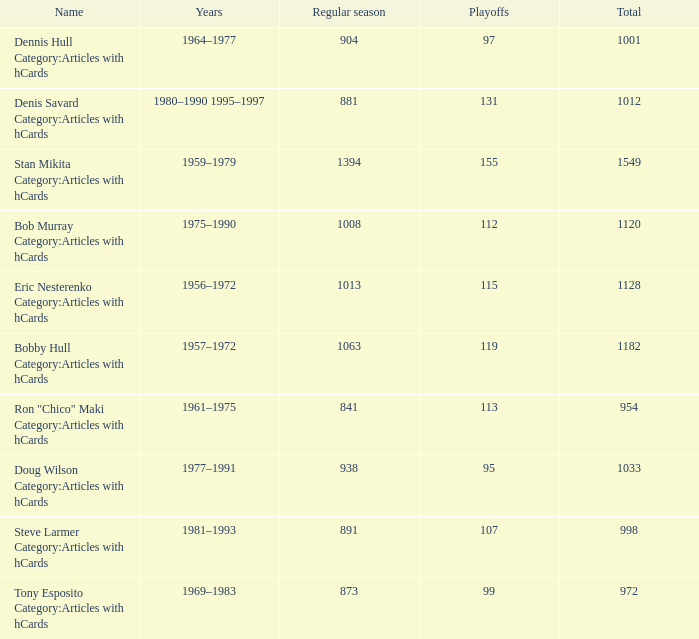What is the years when playoffs is 115? 1956–1972. 